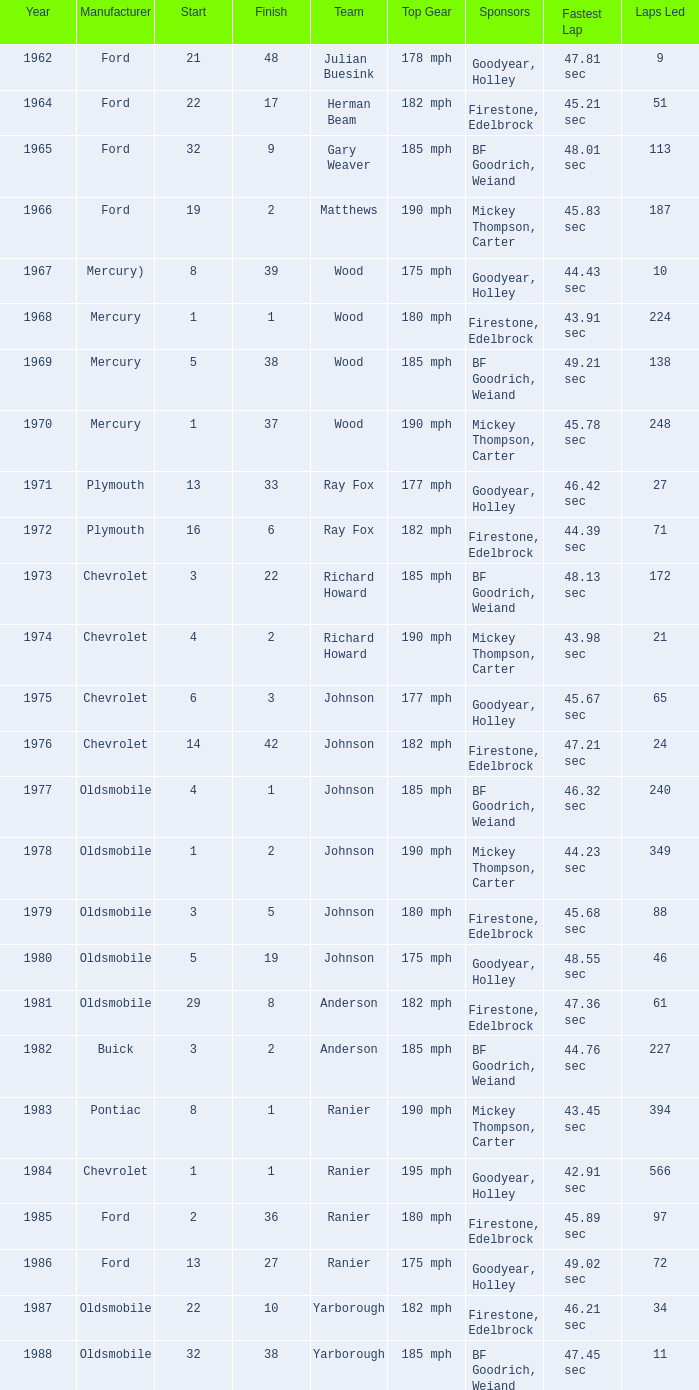What is the smallest finish time for a race where start was less than 3, buick was the manufacturer, and the race was held after 1978? None. 